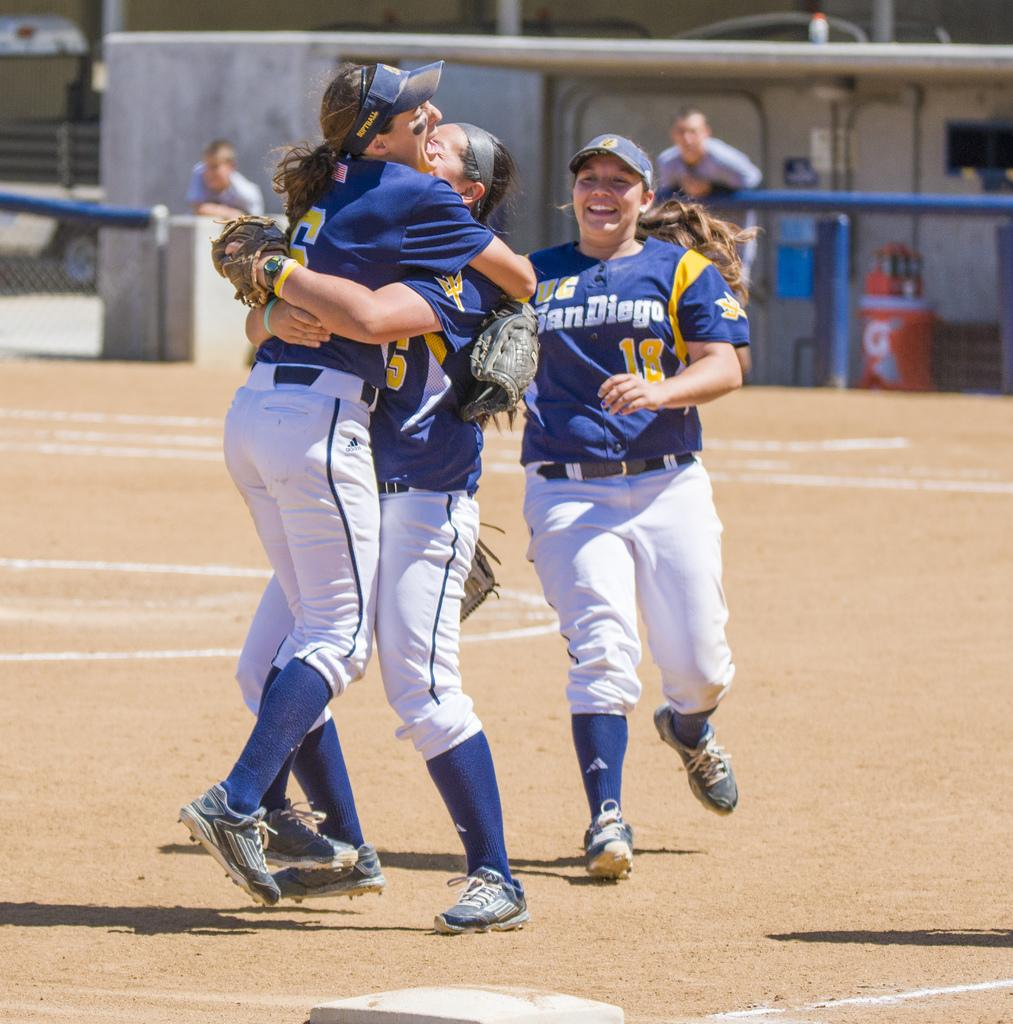<image>
Offer a succinct explanation of the picture presented. Two women hug on a baseball field as another wearing a San Diego uniform runs towards them smiling. 